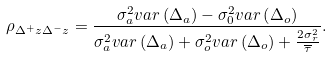Convert formula to latex. <formula><loc_0><loc_0><loc_500><loc_500>\rho _ { \Delta ^ { + } z \Delta ^ { - } z } = \frac { \sigma ^ { 2 } _ { a } v a r \left ( \Delta _ { a } \right ) - \sigma ^ { 2 } _ { 0 } v a r \left ( \Delta _ { o } \right ) } { \sigma _ { a } ^ { 2 } v a r \left ( \Delta _ { a } \right ) + \sigma _ { o } ^ { 2 } v a r \left ( \Delta _ { o } \right ) + \frac { 2 \sigma _ { r } ^ { 2 } } { \overline { \tau } } } .</formula> 